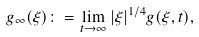<formula> <loc_0><loc_0><loc_500><loc_500>g _ { \infty } ( \xi ) \colon = \lim _ { t \to \infty } { | \xi | } ^ { 1 / 4 } g ( \xi , t ) ,</formula> 